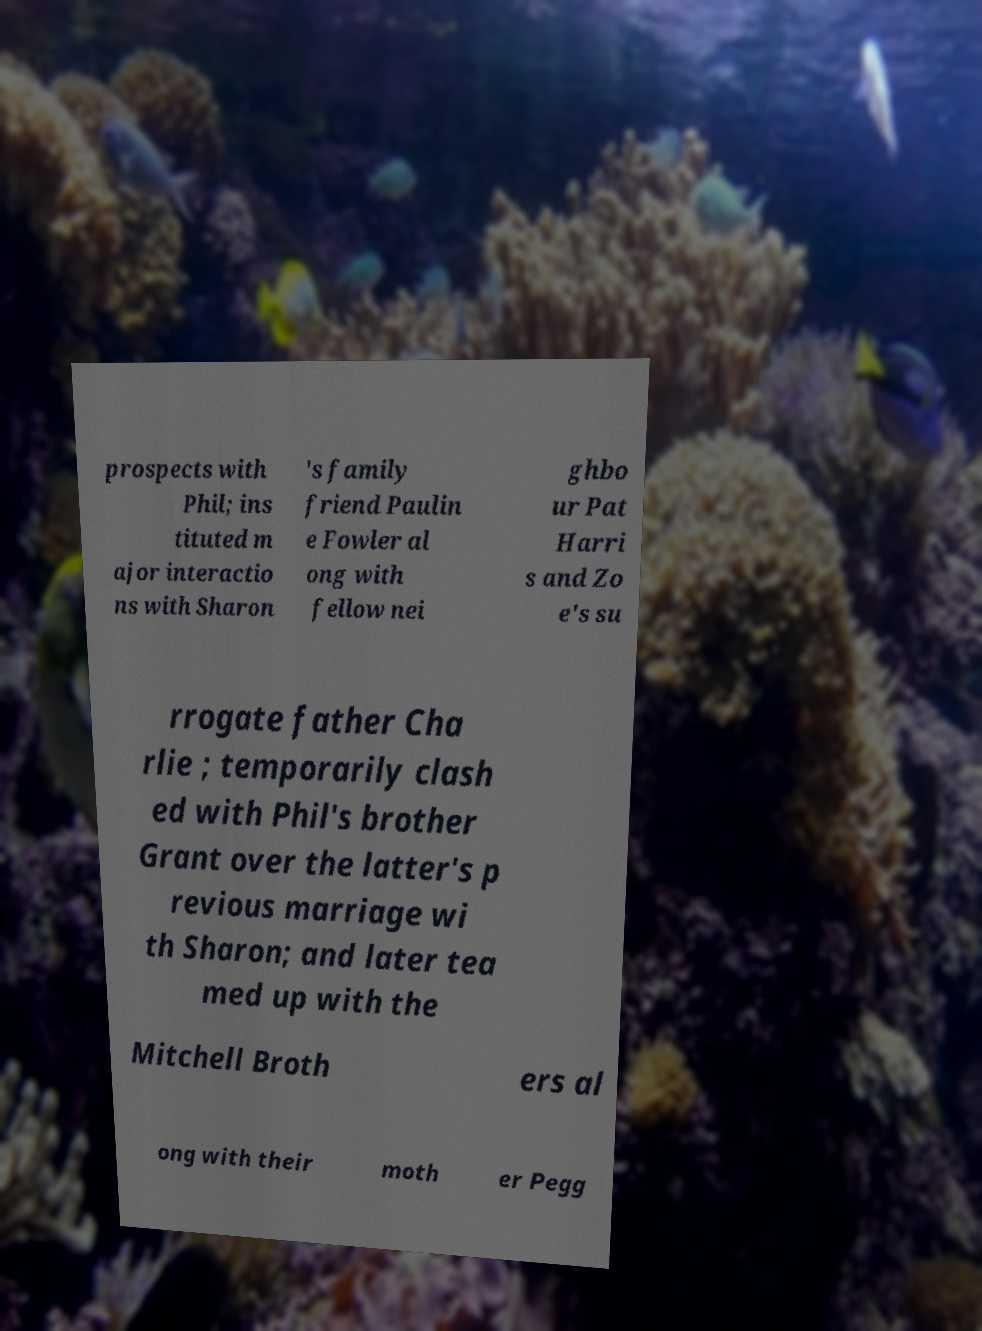Can you accurately transcribe the text from the provided image for me? prospects with Phil; ins tituted m ajor interactio ns with Sharon 's family friend Paulin e Fowler al ong with fellow nei ghbo ur Pat Harri s and Zo e's su rrogate father Cha rlie ; temporarily clash ed with Phil's brother Grant over the latter's p revious marriage wi th Sharon; and later tea med up with the Mitchell Broth ers al ong with their moth er Pegg 